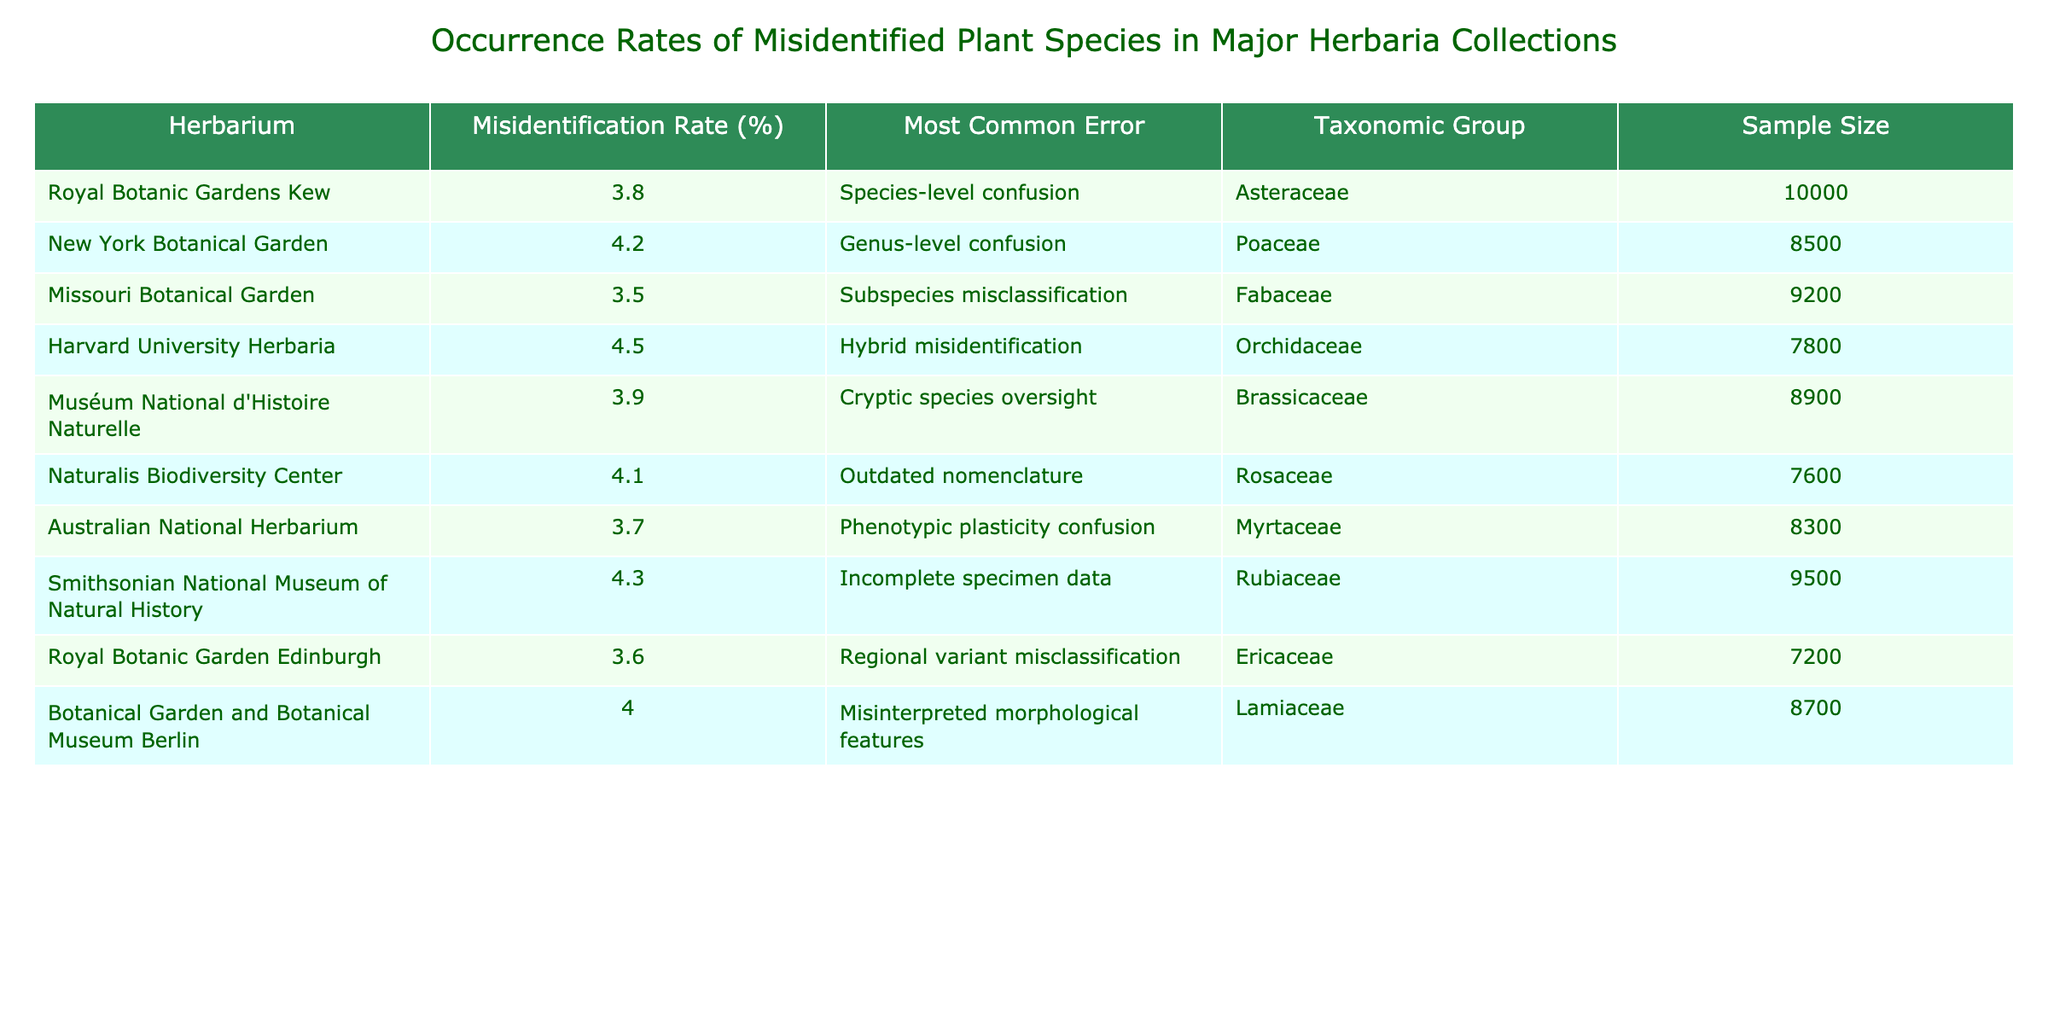What is the misidentification rate for the Royal Botanic Gardens Kew? The table lists the misidentification rate for each herbarium, and for the Royal Botanic Gardens Kew, it is specified as 3.8%.
Answer: 3.8% Which herbarium has the highest misidentification rate? By examining the "Misidentification Rate (%)" column, the highest rate listed is 4.5%, which corresponds to the Harvard University Herbaria.
Answer: 4.5% What taxonomic group is most commonly misidentified at the Smithsonian National Museum of Natural History? The "Taxonomic Group" column shows that for the Smithsonian National Museum of Natural History, the most common error is in the Rubiaceae group.
Answer: Rubiaceae What is the average misidentification rate of all herbaria listed in the table? To find the average, add up all misidentification rates (3.8 + 4.2 + 3.5 + 4.5 + 3.9 + 4.1 + 3.7 + 4.3 + 3.6 + 4.0 = 39.6) and divide by the total number of herbaria (10). Thus, the average is 39.6/10 = 3.96%.
Answer: 3.96% Is it true that the most common error at the Australian National Herbarium is due to phenotypic plasticity confusion? Checking the "Most Common Error" column for the Australian National Herbarium reveals that it is indeed phenotypic plasticity confusion.
Answer: True Which herbarium has a sample size greater than 9000 and a misidentification rate below 4%? By filtering through the table, the Missouri Botanical Garden with a modest misidentification rate of 3.5% and a sample size of 9200 meets these criteria.
Answer: Missouri Botanical Garden What are the two most common errors in misidentifications across all herbaria? The table shows a variety of common errors. The most common errors are hybrid misidentification and genus-level confusion. Therefore, a review of the "Most Common Error" column reveals these as two prominent misidentification issues.
Answer: Hybrid misidentification and genus-level confusion Which taxonomic group has the second highest misidentification rate and what is that rate? Upon reviewing the rates, the group with the second highest misidentification rate is Poaceae at 4.2%.
Answer: 4.2% If we combine the sample sizes of the Royal Botanic Gardens Kew and Muséum National d'Histoire Naturelle, what is the total sample size? The Royal Botanic Gardens Kew has a sample size of 10000 and Muséum National d'Histoire Naturelle has 8900. Adding these gives 10000 + 8900 = 18900.
Answer: 18900 What common misidentification error appears in the Fabaceae taxonomic group? The table indicates that for the Missouri Botanical Garden, the common error in the Fabaceae group is subspecies misclassification.
Answer: Subspecies misclassification 